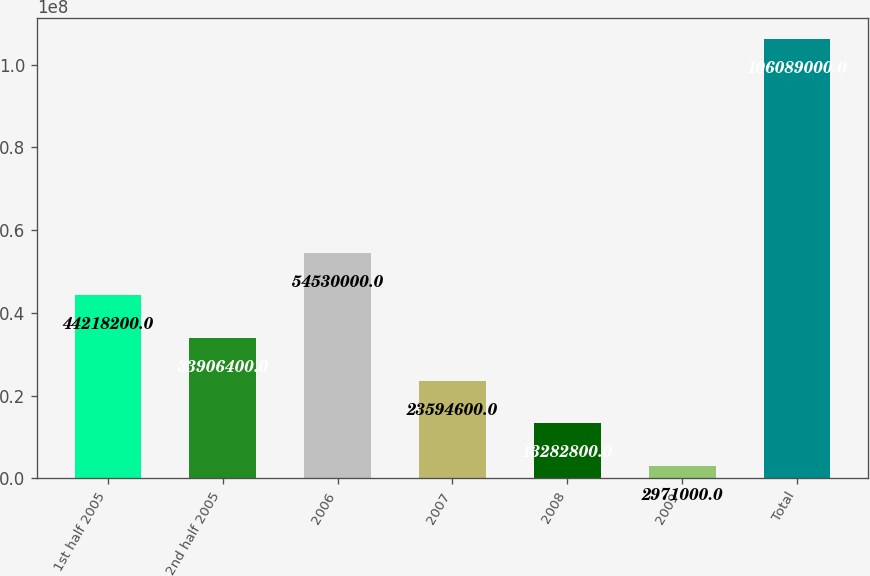Convert chart to OTSL. <chart><loc_0><loc_0><loc_500><loc_500><bar_chart><fcel>1st half 2005<fcel>2nd half 2005<fcel>2006<fcel>2007<fcel>2008<fcel>2009<fcel>Total<nl><fcel>4.42182e+07<fcel>3.39064e+07<fcel>5.453e+07<fcel>2.35946e+07<fcel>1.32828e+07<fcel>2.971e+06<fcel>1.06089e+08<nl></chart> 